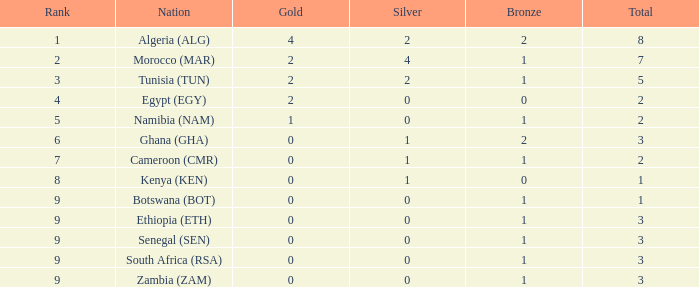What is the highest Total with a Rank that is smaller than 4 and a Nation of tunisia (tun) with a Gold that is smaller than 2? None. 